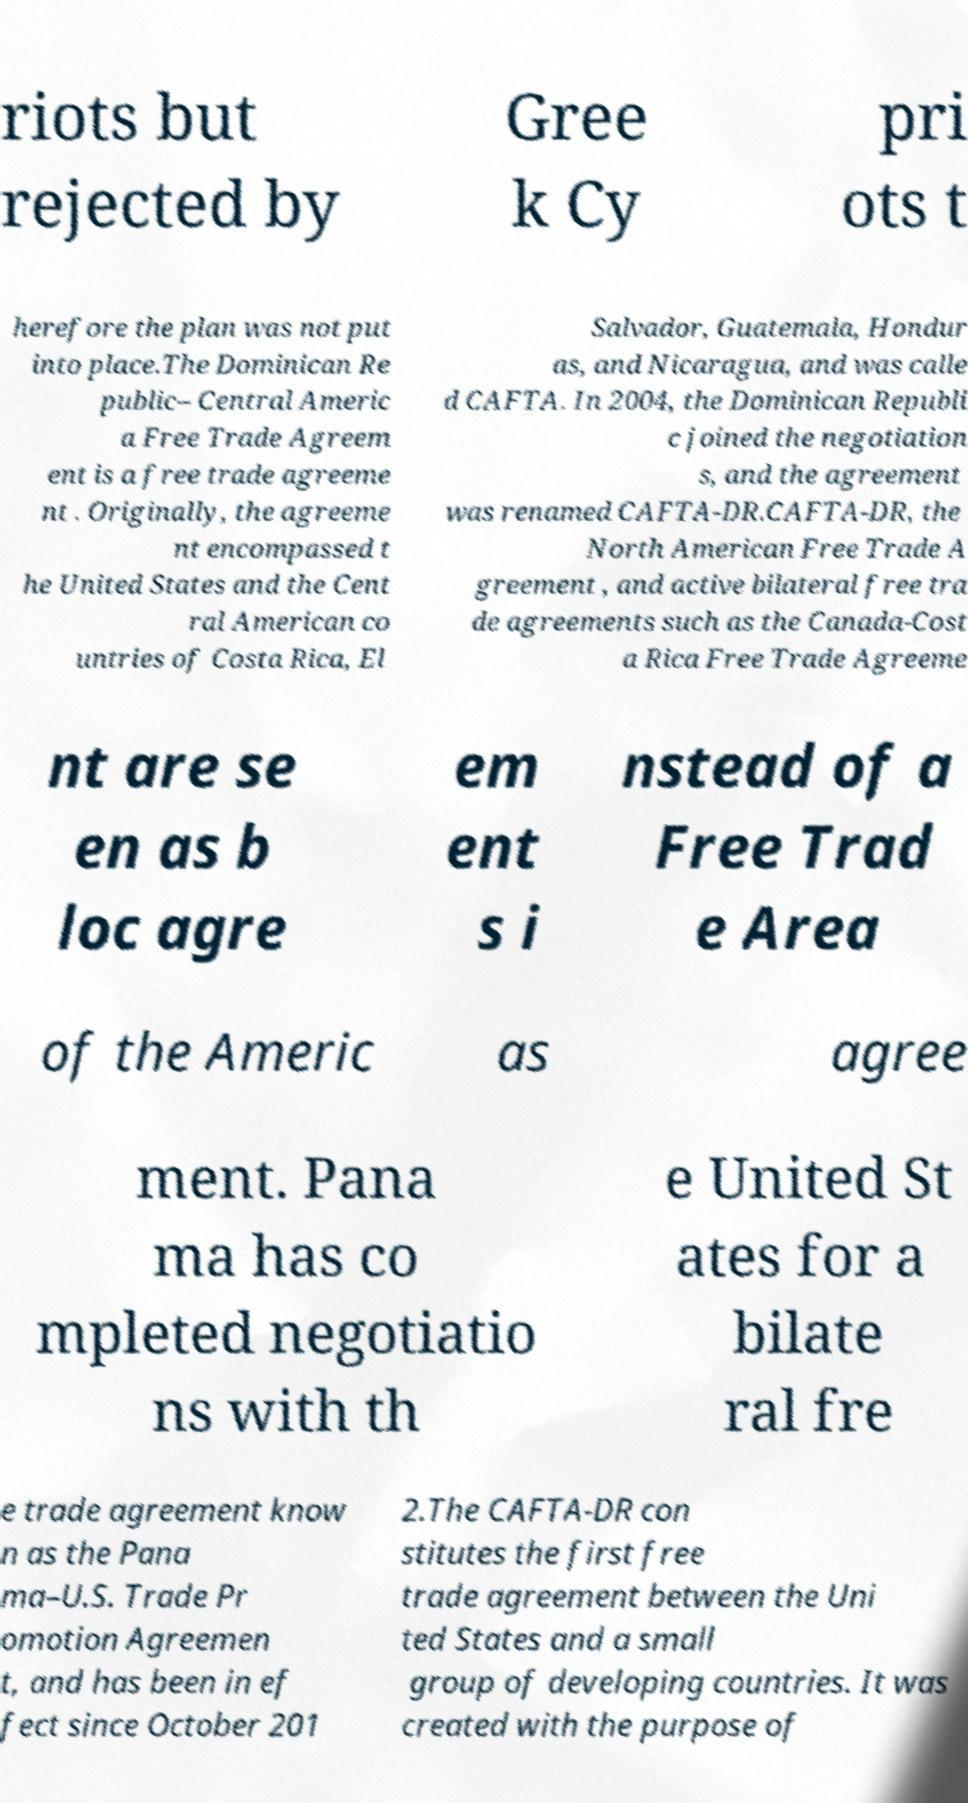Please identify and transcribe the text found in this image. riots but rejected by Gree k Cy pri ots t herefore the plan was not put into place.The Dominican Re public– Central Americ a Free Trade Agreem ent is a free trade agreeme nt . Originally, the agreeme nt encompassed t he United States and the Cent ral American co untries of Costa Rica, El Salvador, Guatemala, Hondur as, and Nicaragua, and was calle d CAFTA. In 2004, the Dominican Republi c joined the negotiation s, and the agreement was renamed CAFTA-DR.CAFTA-DR, the North American Free Trade A greement , and active bilateral free tra de agreements such as the Canada-Cost a Rica Free Trade Agreeme nt are se en as b loc agre em ent s i nstead of a Free Trad e Area of the Americ as agree ment. Pana ma has co mpleted negotiatio ns with th e United St ates for a bilate ral fre e trade agreement know n as the Pana ma–U.S. Trade Pr omotion Agreemen t, and has been in ef fect since October 201 2.The CAFTA-DR con stitutes the first free trade agreement between the Uni ted States and a small group of developing countries. It was created with the purpose of 